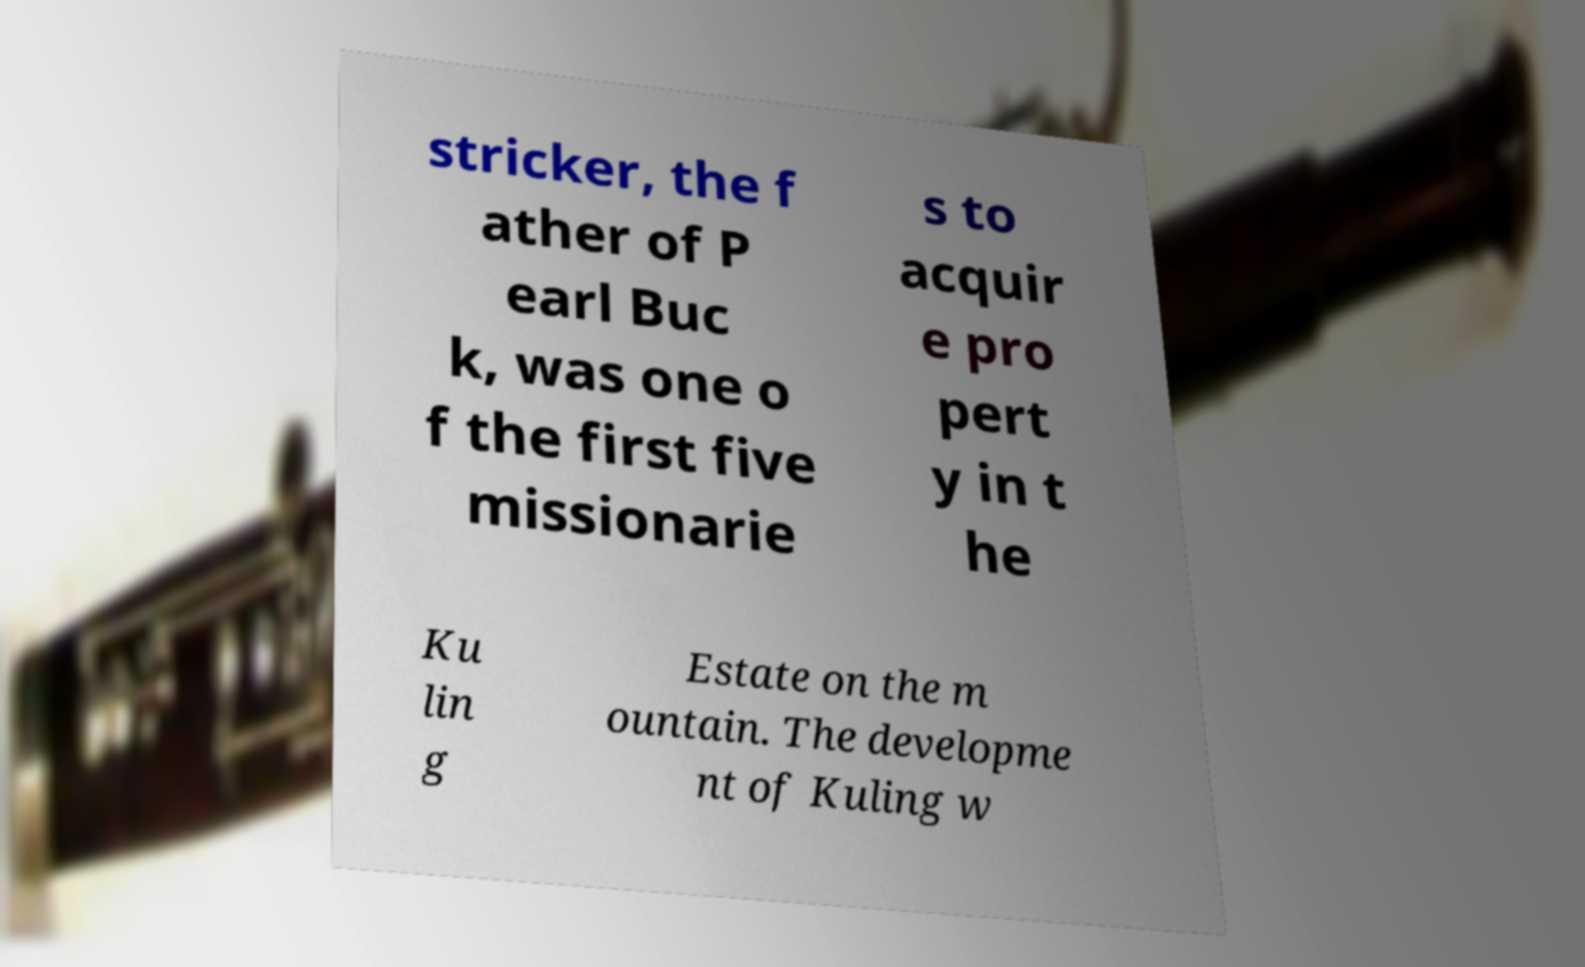Could you assist in decoding the text presented in this image and type it out clearly? stricker, the f ather of P earl Buc k, was one o f the first five missionarie s to acquir e pro pert y in t he Ku lin g Estate on the m ountain. The developme nt of Kuling w 